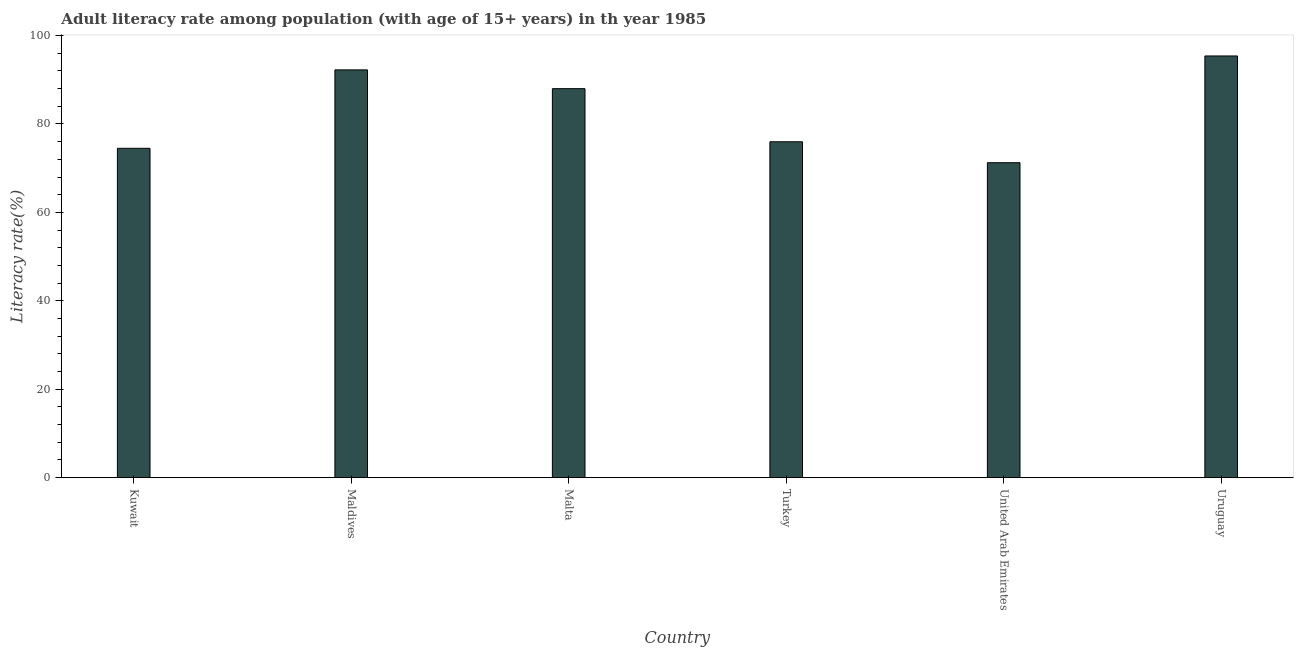What is the title of the graph?
Offer a very short reply. Adult literacy rate among population (with age of 15+ years) in th year 1985. What is the label or title of the Y-axis?
Your answer should be compact. Literacy rate(%). What is the adult literacy rate in Turkey?
Your answer should be compact. 75.97. Across all countries, what is the maximum adult literacy rate?
Make the answer very short. 95.38. Across all countries, what is the minimum adult literacy rate?
Offer a terse response. 71.24. In which country was the adult literacy rate maximum?
Provide a short and direct response. Uruguay. In which country was the adult literacy rate minimum?
Your answer should be very brief. United Arab Emirates. What is the sum of the adult literacy rate?
Your answer should be compact. 497.29. What is the difference between the adult literacy rate in Malta and Uruguay?
Provide a succinct answer. -7.4. What is the average adult literacy rate per country?
Your answer should be very brief. 82.88. What is the median adult literacy rate?
Offer a very short reply. 81.98. In how many countries, is the adult literacy rate greater than 44 %?
Your answer should be compact. 6. What is the ratio of the adult literacy rate in United Arab Emirates to that in Uruguay?
Provide a short and direct response. 0.75. What is the difference between the highest and the second highest adult literacy rate?
Your answer should be very brief. 3.15. Is the sum of the adult literacy rate in Turkey and Uruguay greater than the maximum adult literacy rate across all countries?
Your answer should be very brief. Yes. What is the difference between the highest and the lowest adult literacy rate?
Your answer should be very brief. 24.14. How many bars are there?
Provide a succinct answer. 6. How many countries are there in the graph?
Ensure brevity in your answer.  6. Are the values on the major ticks of Y-axis written in scientific E-notation?
Keep it short and to the point. No. What is the Literacy rate(%) in Kuwait?
Provide a succinct answer. 74.49. What is the Literacy rate(%) of Maldives?
Provide a succinct answer. 92.23. What is the Literacy rate(%) in Malta?
Your answer should be compact. 87.98. What is the Literacy rate(%) of Turkey?
Your answer should be compact. 75.97. What is the Literacy rate(%) of United Arab Emirates?
Ensure brevity in your answer.  71.24. What is the Literacy rate(%) of Uruguay?
Your answer should be very brief. 95.38. What is the difference between the Literacy rate(%) in Kuwait and Maldives?
Provide a succinct answer. -17.74. What is the difference between the Literacy rate(%) in Kuwait and Malta?
Ensure brevity in your answer.  -13.49. What is the difference between the Literacy rate(%) in Kuwait and Turkey?
Provide a succinct answer. -1.48. What is the difference between the Literacy rate(%) in Kuwait and United Arab Emirates?
Keep it short and to the point. 3.26. What is the difference between the Literacy rate(%) in Kuwait and Uruguay?
Offer a very short reply. -20.89. What is the difference between the Literacy rate(%) in Maldives and Malta?
Offer a very short reply. 4.25. What is the difference between the Literacy rate(%) in Maldives and Turkey?
Provide a succinct answer. 16.26. What is the difference between the Literacy rate(%) in Maldives and United Arab Emirates?
Your answer should be very brief. 20.99. What is the difference between the Literacy rate(%) in Maldives and Uruguay?
Provide a short and direct response. -3.15. What is the difference between the Literacy rate(%) in Malta and Turkey?
Keep it short and to the point. 12.01. What is the difference between the Literacy rate(%) in Malta and United Arab Emirates?
Provide a succinct answer. 16.75. What is the difference between the Literacy rate(%) in Malta and Uruguay?
Your answer should be compact. -7.4. What is the difference between the Literacy rate(%) in Turkey and United Arab Emirates?
Provide a succinct answer. 4.73. What is the difference between the Literacy rate(%) in Turkey and Uruguay?
Make the answer very short. -19.41. What is the difference between the Literacy rate(%) in United Arab Emirates and Uruguay?
Offer a very short reply. -24.14. What is the ratio of the Literacy rate(%) in Kuwait to that in Maldives?
Offer a very short reply. 0.81. What is the ratio of the Literacy rate(%) in Kuwait to that in Malta?
Give a very brief answer. 0.85. What is the ratio of the Literacy rate(%) in Kuwait to that in United Arab Emirates?
Make the answer very short. 1.05. What is the ratio of the Literacy rate(%) in Kuwait to that in Uruguay?
Give a very brief answer. 0.78. What is the ratio of the Literacy rate(%) in Maldives to that in Malta?
Offer a very short reply. 1.05. What is the ratio of the Literacy rate(%) in Maldives to that in Turkey?
Your answer should be compact. 1.21. What is the ratio of the Literacy rate(%) in Maldives to that in United Arab Emirates?
Provide a succinct answer. 1.29. What is the ratio of the Literacy rate(%) in Maldives to that in Uruguay?
Offer a terse response. 0.97. What is the ratio of the Literacy rate(%) in Malta to that in Turkey?
Give a very brief answer. 1.16. What is the ratio of the Literacy rate(%) in Malta to that in United Arab Emirates?
Your answer should be compact. 1.24. What is the ratio of the Literacy rate(%) in Malta to that in Uruguay?
Make the answer very short. 0.92. What is the ratio of the Literacy rate(%) in Turkey to that in United Arab Emirates?
Keep it short and to the point. 1.07. What is the ratio of the Literacy rate(%) in Turkey to that in Uruguay?
Your response must be concise. 0.8. What is the ratio of the Literacy rate(%) in United Arab Emirates to that in Uruguay?
Give a very brief answer. 0.75. 